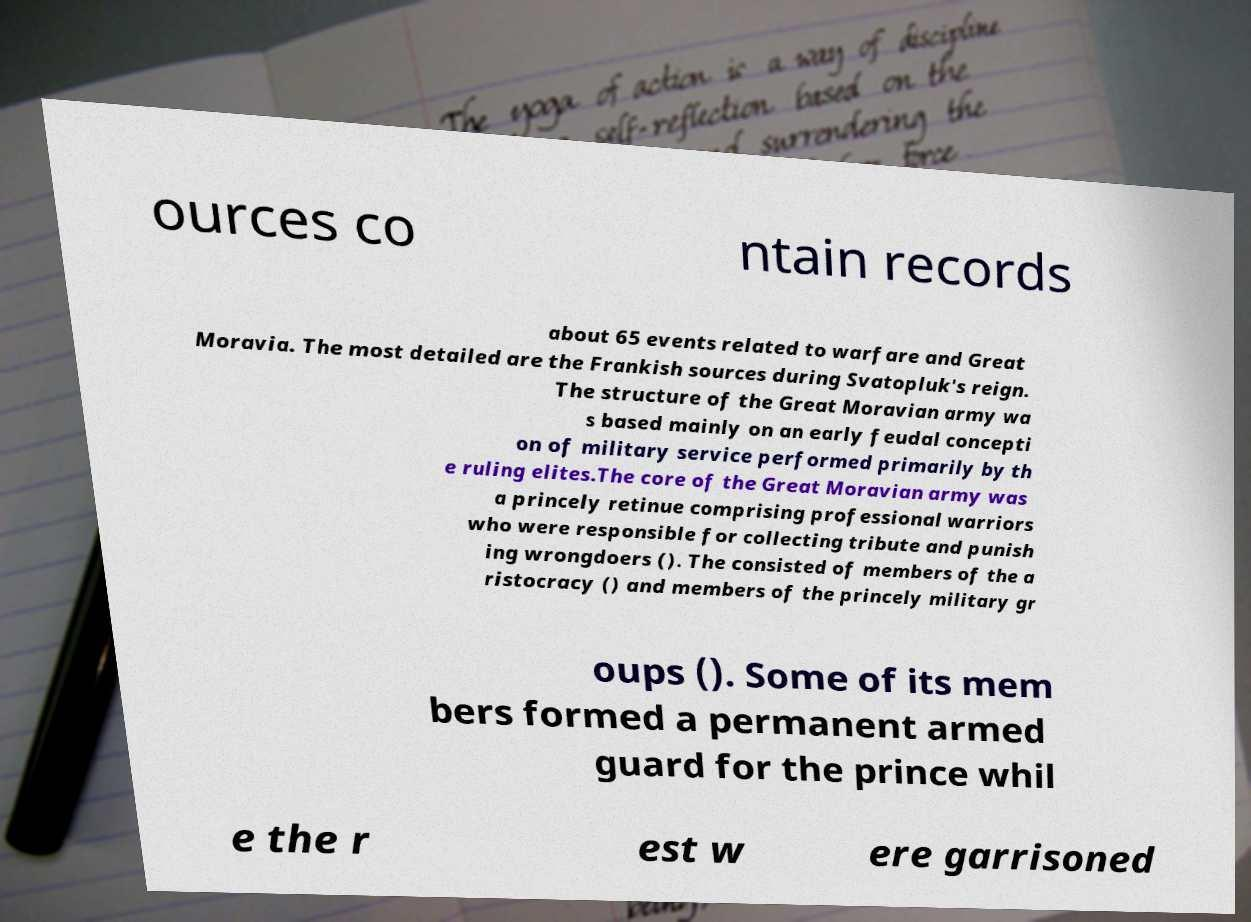Can you accurately transcribe the text from the provided image for me? ources co ntain records about 65 events related to warfare and Great Moravia. The most detailed are the Frankish sources during Svatopluk's reign. The structure of the Great Moravian army wa s based mainly on an early feudal concepti on of military service performed primarily by th e ruling elites.The core of the Great Moravian army was a princely retinue comprising professional warriors who were responsible for collecting tribute and punish ing wrongdoers (). The consisted of members of the a ristocracy () and members of the princely military gr oups (). Some of its mem bers formed a permanent armed guard for the prince whil e the r est w ere garrisoned 